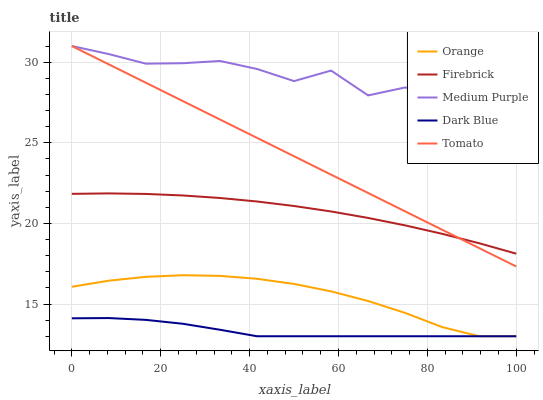Does Dark Blue have the minimum area under the curve?
Answer yes or no. Yes. Does Medium Purple have the maximum area under the curve?
Answer yes or no. Yes. Does Firebrick have the minimum area under the curve?
Answer yes or no. No. Does Firebrick have the maximum area under the curve?
Answer yes or no. No. Is Tomato the smoothest?
Answer yes or no. Yes. Is Medium Purple the roughest?
Answer yes or no. Yes. Is Firebrick the smoothest?
Answer yes or no. No. Is Firebrick the roughest?
Answer yes or no. No. Does Orange have the lowest value?
Answer yes or no. Yes. Does Firebrick have the lowest value?
Answer yes or no. No. Does Tomato have the highest value?
Answer yes or no. Yes. Does Firebrick have the highest value?
Answer yes or no. No. Is Dark Blue less than Firebrick?
Answer yes or no. Yes. Is Tomato greater than Orange?
Answer yes or no. Yes. Does Firebrick intersect Tomato?
Answer yes or no. Yes. Is Firebrick less than Tomato?
Answer yes or no. No. Is Firebrick greater than Tomato?
Answer yes or no. No. Does Dark Blue intersect Firebrick?
Answer yes or no. No. 